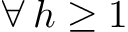<formula> <loc_0><loc_0><loc_500><loc_500>\forall \, h \geq 1</formula> 